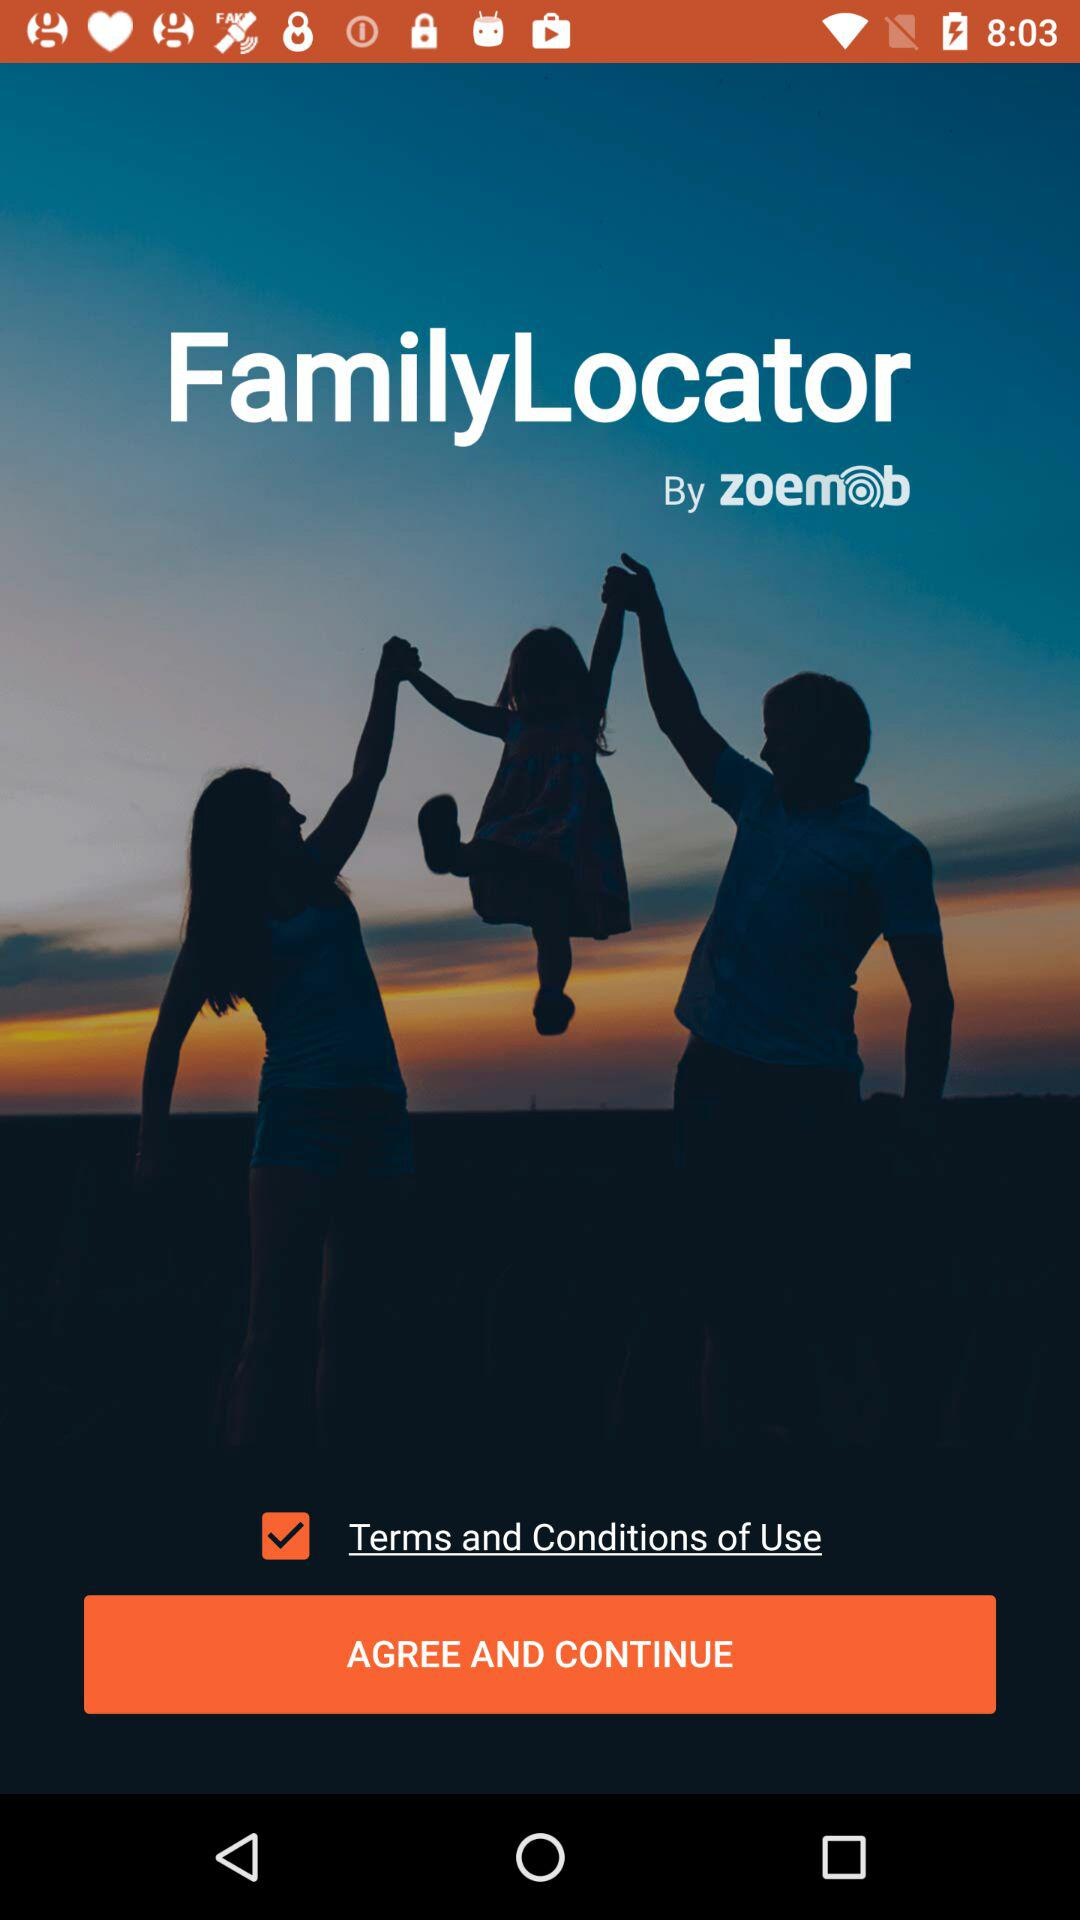What is the name of the application? The name of the application is "FamilyLocator". 